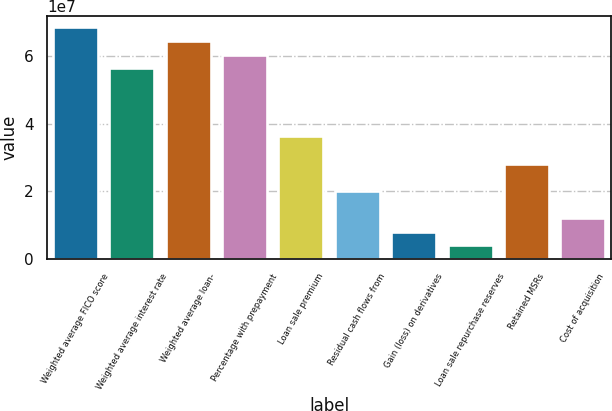Convert chart. <chart><loc_0><loc_0><loc_500><loc_500><bar_chart><fcel>Weighted average FICO score<fcel>Weighted average interest rate<fcel>Weighted average loan-<fcel>Percentage with prepayment<fcel>Loan sale premium<fcel>Residual cash flows from<fcel>Gain (loss) on derivatives<fcel>Loan sale repurchase reserves<fcel>Retained MSRs<fcel>Cost of acquisition<nl><fcel>6.84628e+07<fcel>5.63811e+07<fcel>6.44356e+07<fcel>6.04083e+07<fcel>3.6245e+07<fcel>2.01361e+07<fcel>8.05445e+06<fcel>4.02722e+06<fcel>2.81906e+07<fcel>1.20817e+07<nl></chart> 